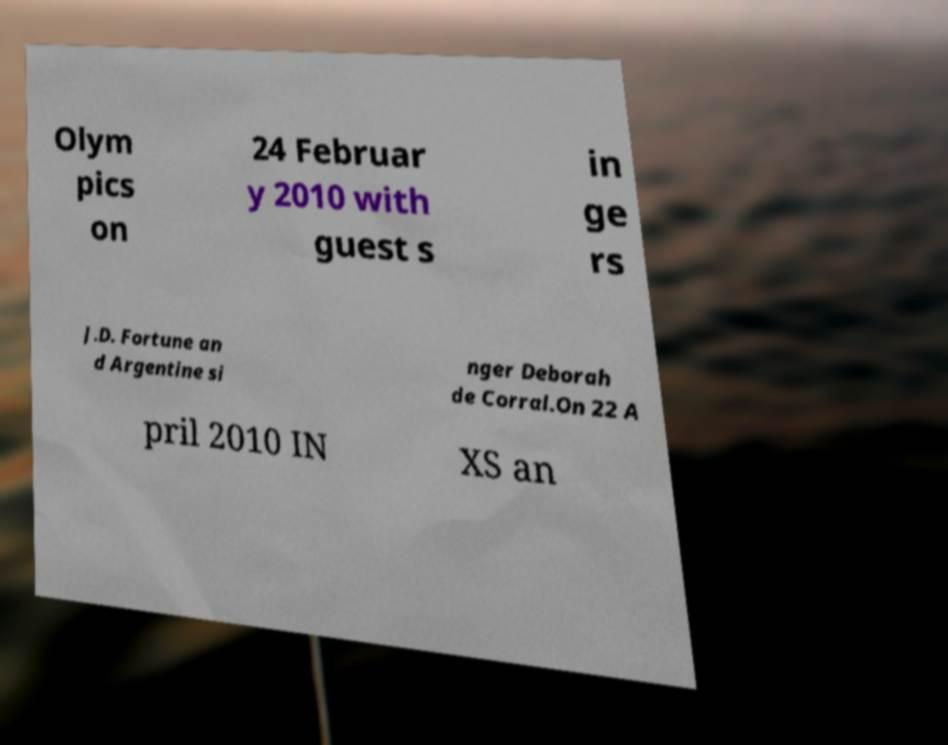There's text embedded in this image that I need extracted. Can you transcribe it verbatim? Olym pics on 24 Februar y 2010 with guest s in ge rs J.D. Fortune an d Argentine si nger Deborah de Corral.On 22 A pril 2010 IN XS an 